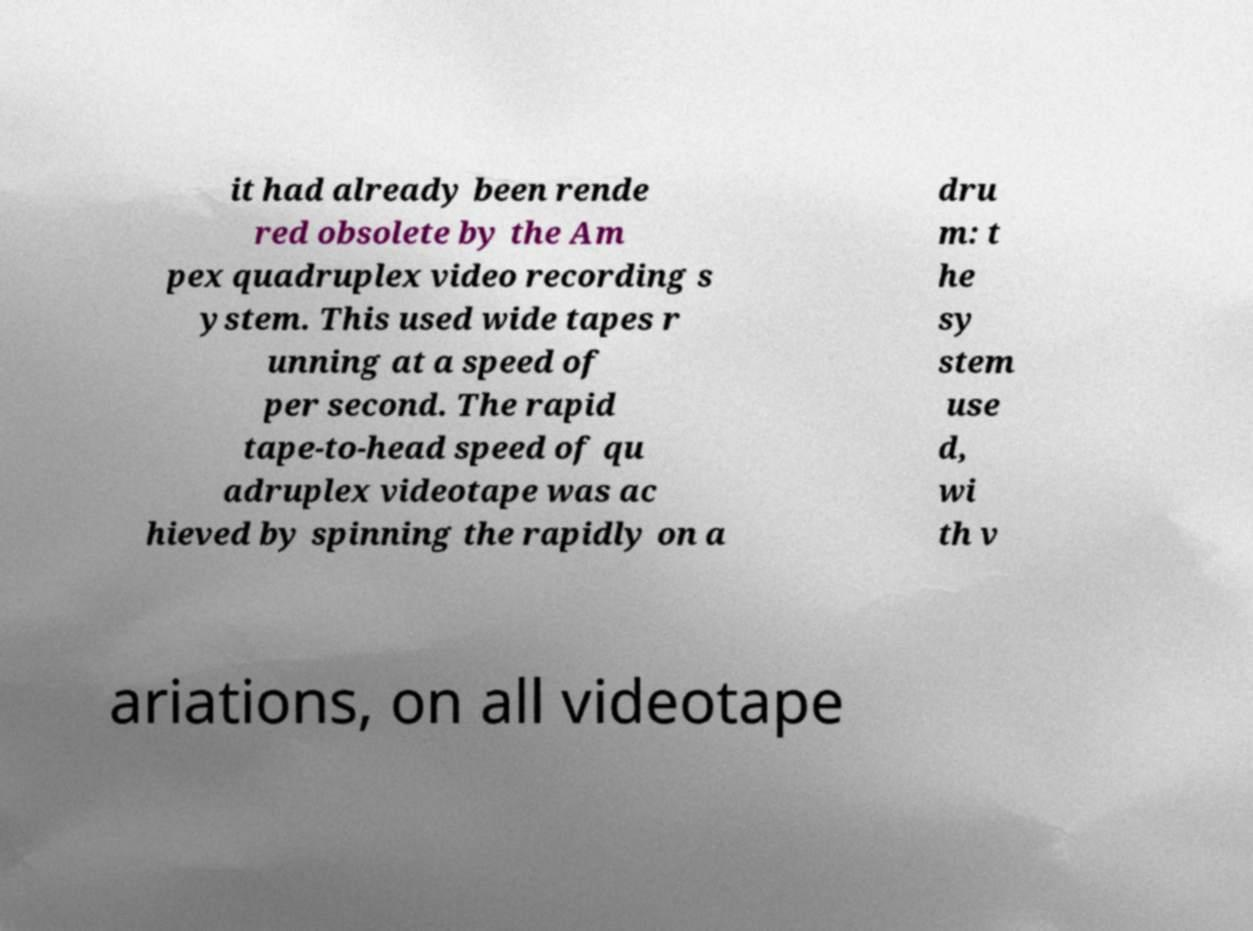What messages or text are displayed in this image? I need them in a readable, typed format. it had already been rende red obsolete by the Am pex quadruplex video recording s ystem. This used wide tapes r unning at a speed of per second. The rapid tape-to-head speed of qu adruplex videotape was ac hieved by spinning the rapidly on a dru m: t he sy stem use d, wi th v ariations, on all videotape 